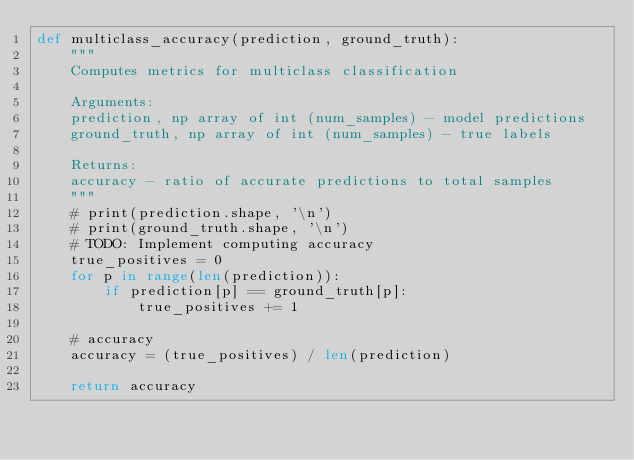Convert code to text. <code><loc_0><loc_0><loc_500><loc_500><_Python_>def multiclass_accuracy(prediction, ground_truth):
    """
    Computes metrics for multiclass classification

    Arguments:
    prediction, np array of int (num_samples) - model predictions
    ground_truth, np array of int (num_samples) - true labels

    Returns:
    accuracy - ratio of accurate predictions to total samples
    """
    # print(prediction.shape, '\n')
    # print(ground_truth.shape, '\n')
    # TODO: Implement computing accuracy
    true_positives = 0
    for p in range(len(prediction)):
        if prediction[p] == ground_truth[p]:
            true_positives += 1

    # accuracy
    accuracy = (true_positives) / len(prediction)

    return accuracy
</code> 